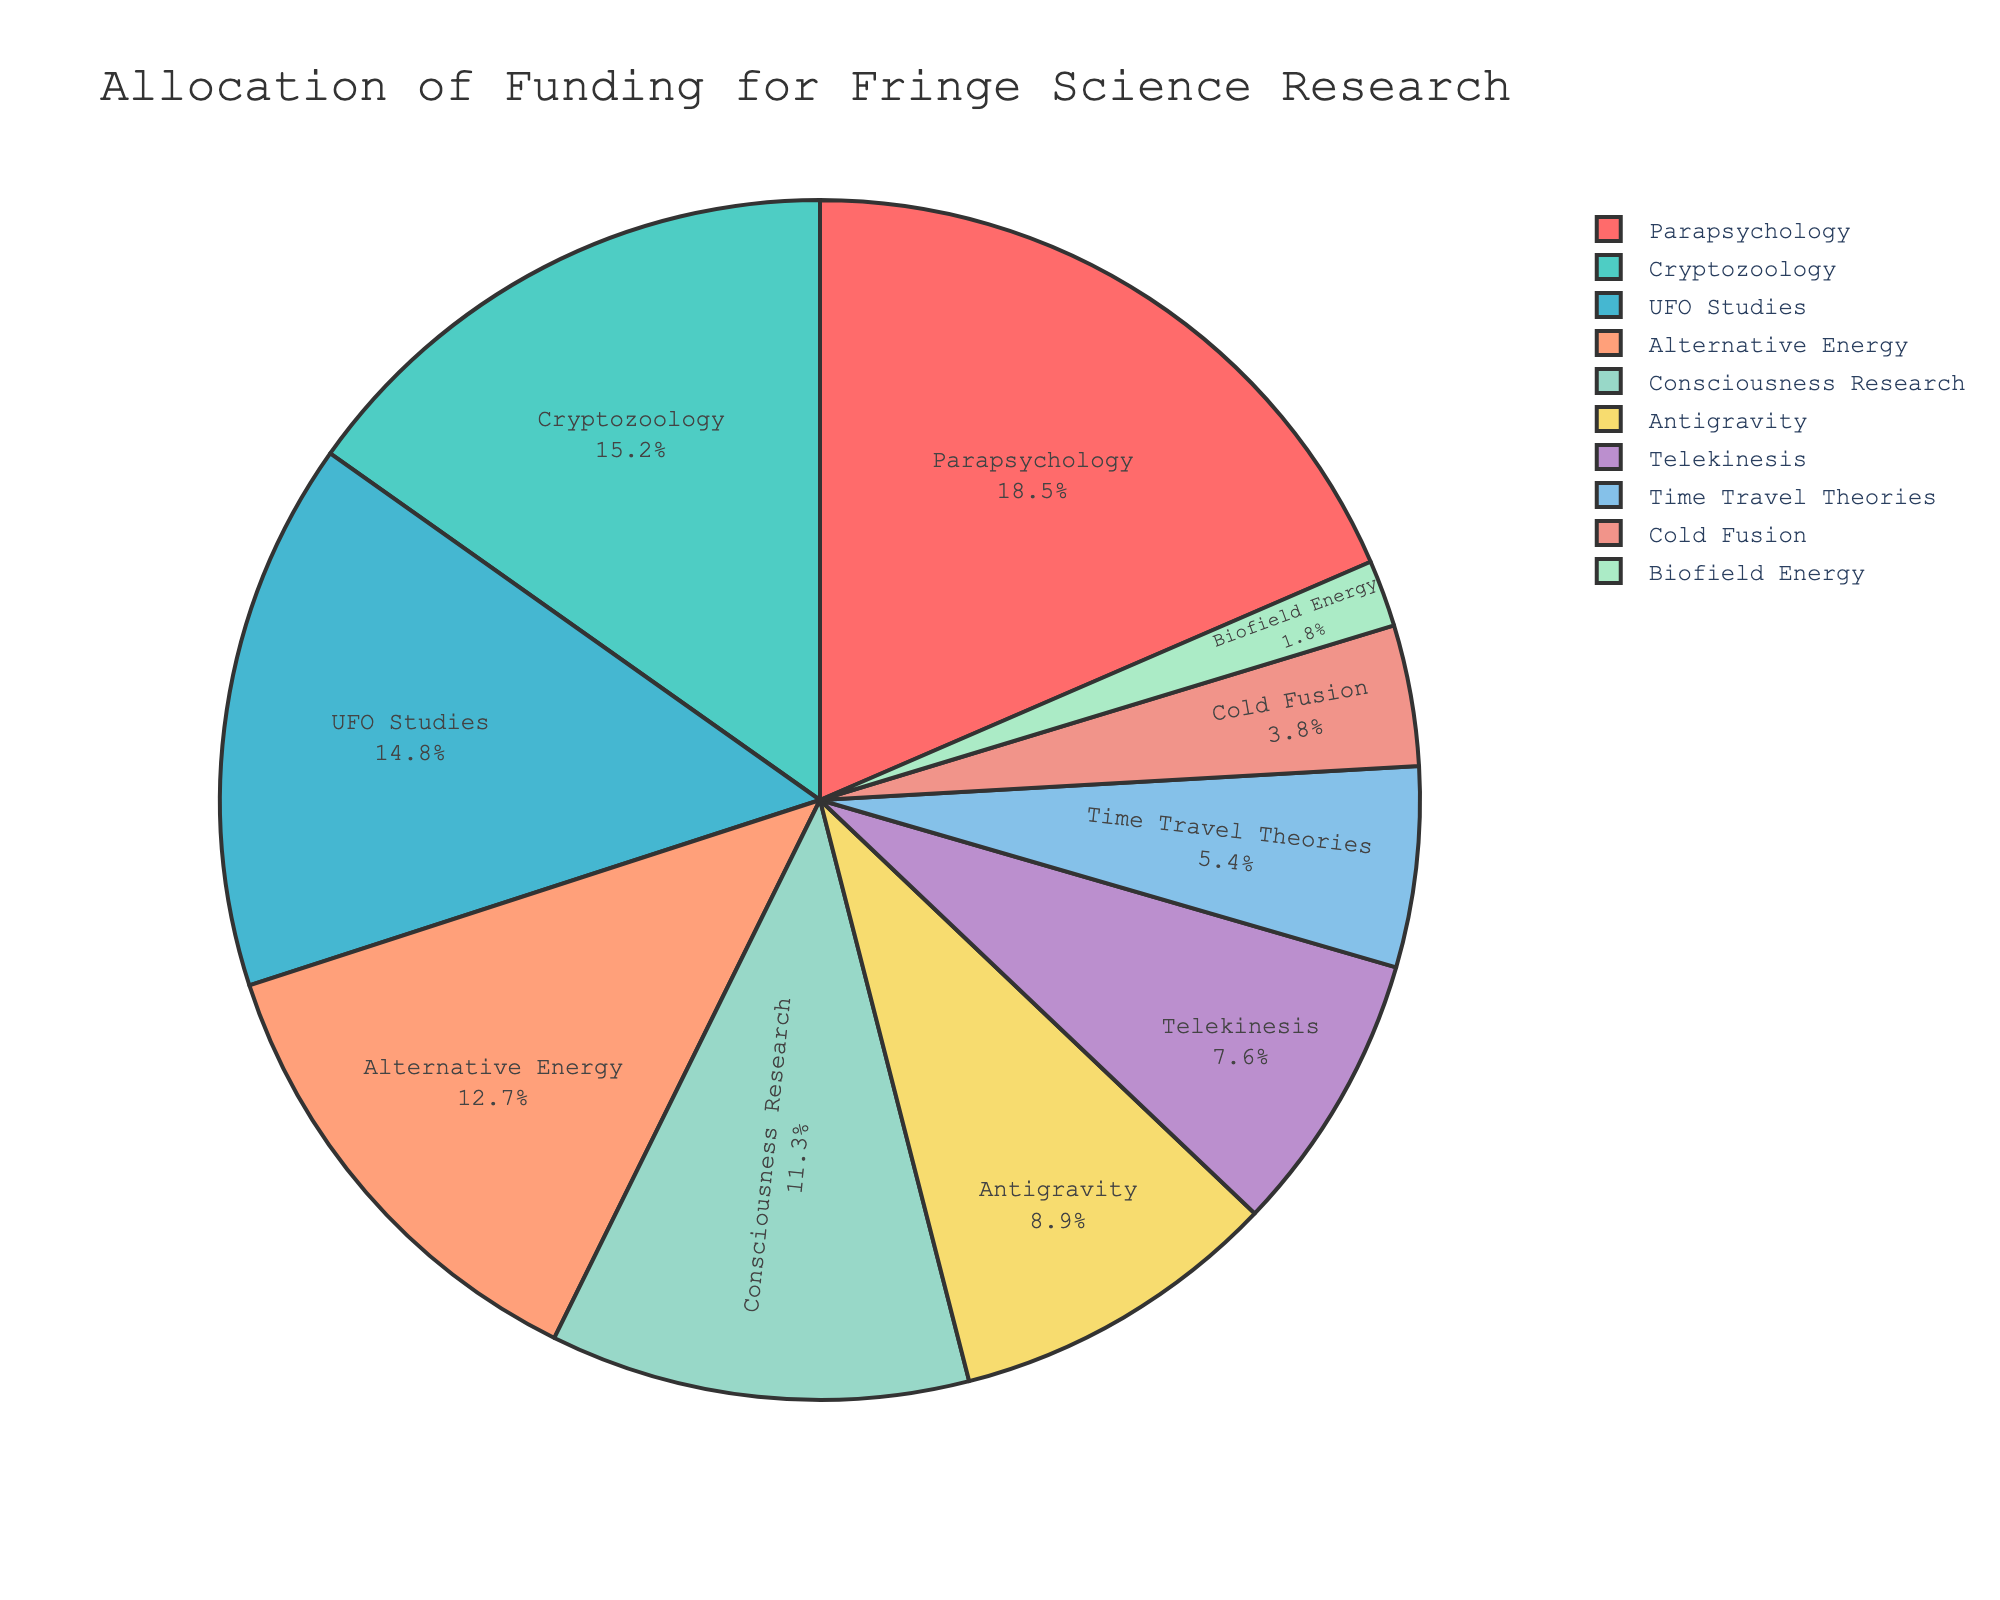Which field receives the highest percentage of funding? The pie chart shows various funding percentages, and by looking at the segments, we can identify the largest one. "Parapsychology" has the largest segment.
Answer: Parapsychology What is the combined funding percentage for UFO Studies and Cryptozoology? From the pie chart, UFO Studies has 14.8% and Cryptozoology has 15.2%. Adding these percentages gives us 14.8 + 15.2 = 30.0%.
Answer: 30.0% Which field receives slightly more funding, Consciousness Research or Alternative Energy, and by how much? Consciousness Research gets 11.3% and Alternative Energy receives 12.7%. Subtract 11.3 from 12.7 to find the difference: 12.7 - 11.3 = 1.4%.
Answer: Alternative Energy by 1.4% Is the combined funding for Telekinesis and Time Travel Theories less than Cryptozoology? Telekinesis has 7.6% and Time Travel Theories has 5.4%. Adding these gives 7.6 + 5.4 = 13.0%. Since Cryptozoology has 15.2%, 13.0% is less than 15.2%.
Answer: Yes Rank the top three fields by their percentage of funding. The highest funding percentage is for Parapsychology (18.5%), followed by Cryptozoology (15.2%), and then UFO Studies (14.8%).
Answer: Parapsychology, Cryptozoology, UFO Studies What is the funding percentage difference between Parapsychology and Biofield Energy? Parapsychology has 18.5% and Biofield Energy has 1.8%. Subtracting 1.8 from 18.5 gives 18.5 - 1.8 = 16.7%.
Answer: 16.7% Which field receives nearly twice the funding of Telekinesis? Telekinesis has 7.6%. Double this is 7.6 * 2 = 15.2%. Cryptozoology receives 15.2%, which is nearly twice the funding of Telekinesis.
Answer: Cryptozoology Is the funding for Alternative Energy greater than that for Consciousness Research and Cold Fusion combined? Alternative Energy has 12.7%, while Consciousness Research has 11.3% and Cold Fusion has 3.8%. Adding Consciousness Research and Cold Fusion gives 11.3 + 3.8 = 15.1%, which is greater than 12.7%.
Answer: No Which field's funding is closest to the average percentage of funding across all fields? There are 10 fields. The total funding percentage is 100%. The average is 100 / 10 = 10%. Consciousness Research at 11.3% is closest to 10%.
Answer: Consciousness Research 